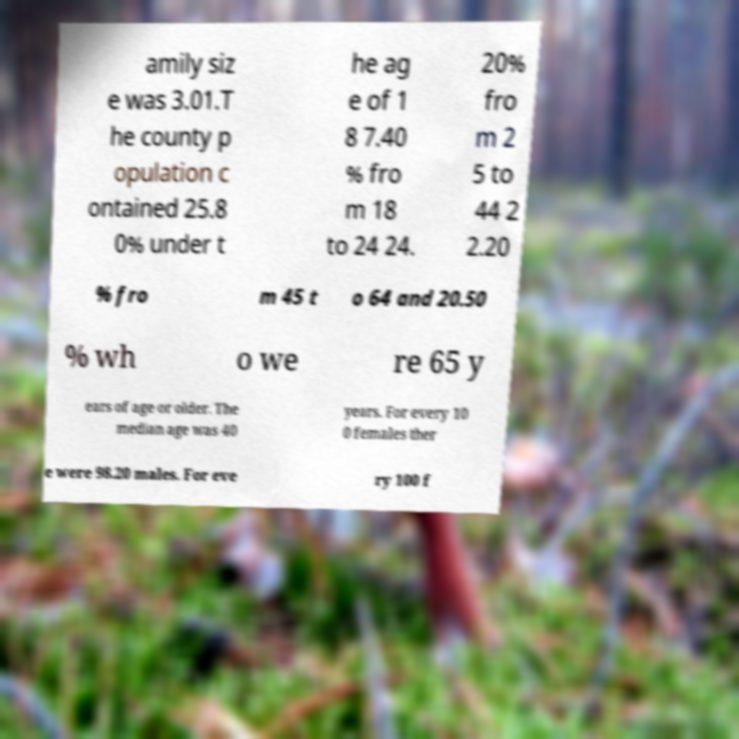What messages or text are displayed in this image? I need them in a readable, typed format. amily siz e was 3.01.T he county p opulation c ontained 25.8 0% under t he ag e of 1 8 7.40 % fro m 18 to 24 24. 20% fro m 2 5 to 44 2 2.20 % fro m 45 t o 64 and 20.50 % wh o we re 65 y ears of age or older. The median age was 40 years. For every 10 0 females ther e were 98.20 males. For eve ry 100 f 